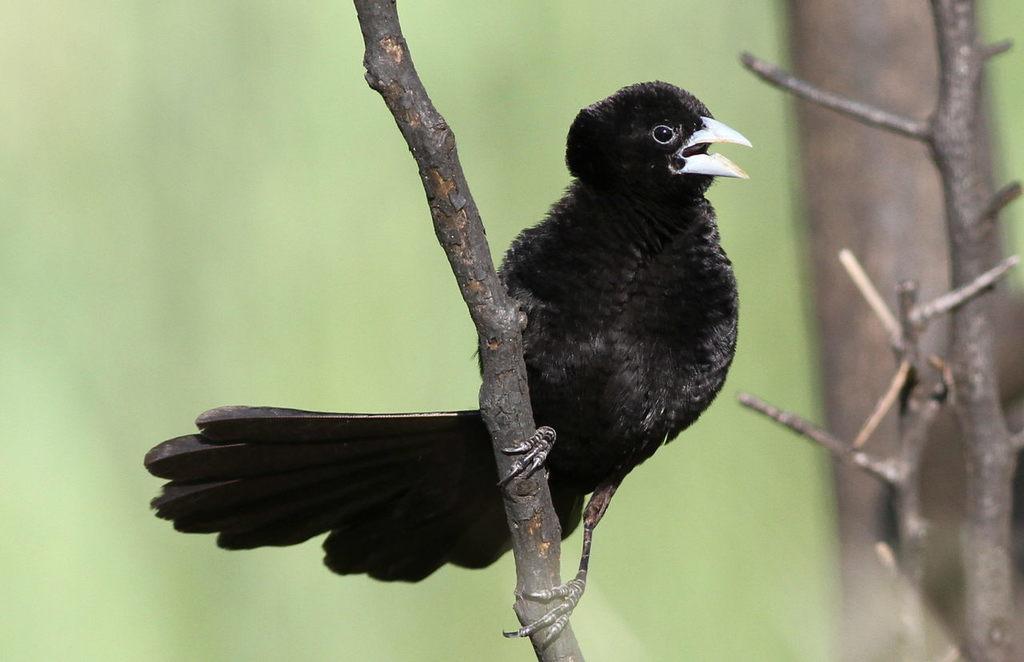In one or two sentences, can you explain what this image depicts? In this image there is a bird on the branch of the tree and green color background. 